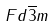Convert formula to latex. <formula><loc_0><loc_0><loc_500><loc_500>F d \overline { 3 } m</formula> 